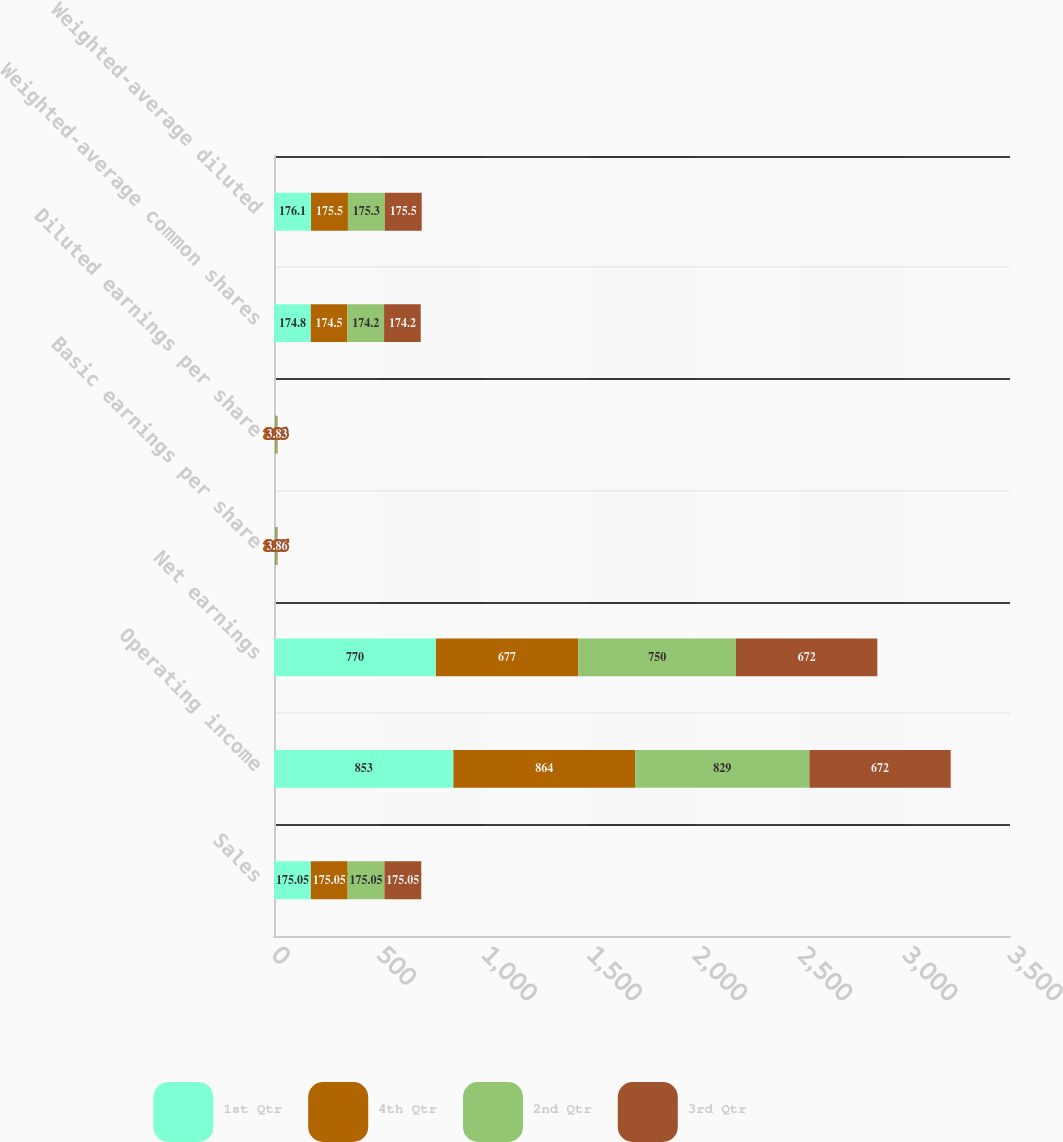<chart> <loc_0><loc_0><loc_500><loc_500><stacked_bar_chart><ecel><fcel>Sales<fcel>Operating income<fcel>Net earnings<fcel>Basic earnings per share<fcel>Diluted earnings per share<fcel>Weighted-average common shares<fcel>Weighted-average diluted<nl><fcel>1st Qtr<fcel>175.05<fcel>853<fcel>770<fcel>4.41<fcel>4.37<fcel>174.8<fcel>176.1<nl><fcel>4th Qtr<fcel>175.05<fcel>864<fcel>677<fcel>3.88<fcel>3.86<fcel>174.5<fcel>175.5<nl><fcel>2nd Qtr<fcel>175.05<fcel>829<fcel>750<fcel>4.31<fcel>4.28<fcel>174.2<fcel>175.3<nl><fcel>3rd Qtr<fcel>175.05<fcel>672<fcel>672<fcel>3.86<fcel>3.83<fcel>174.2<fcel>175.5<nl></chart> 